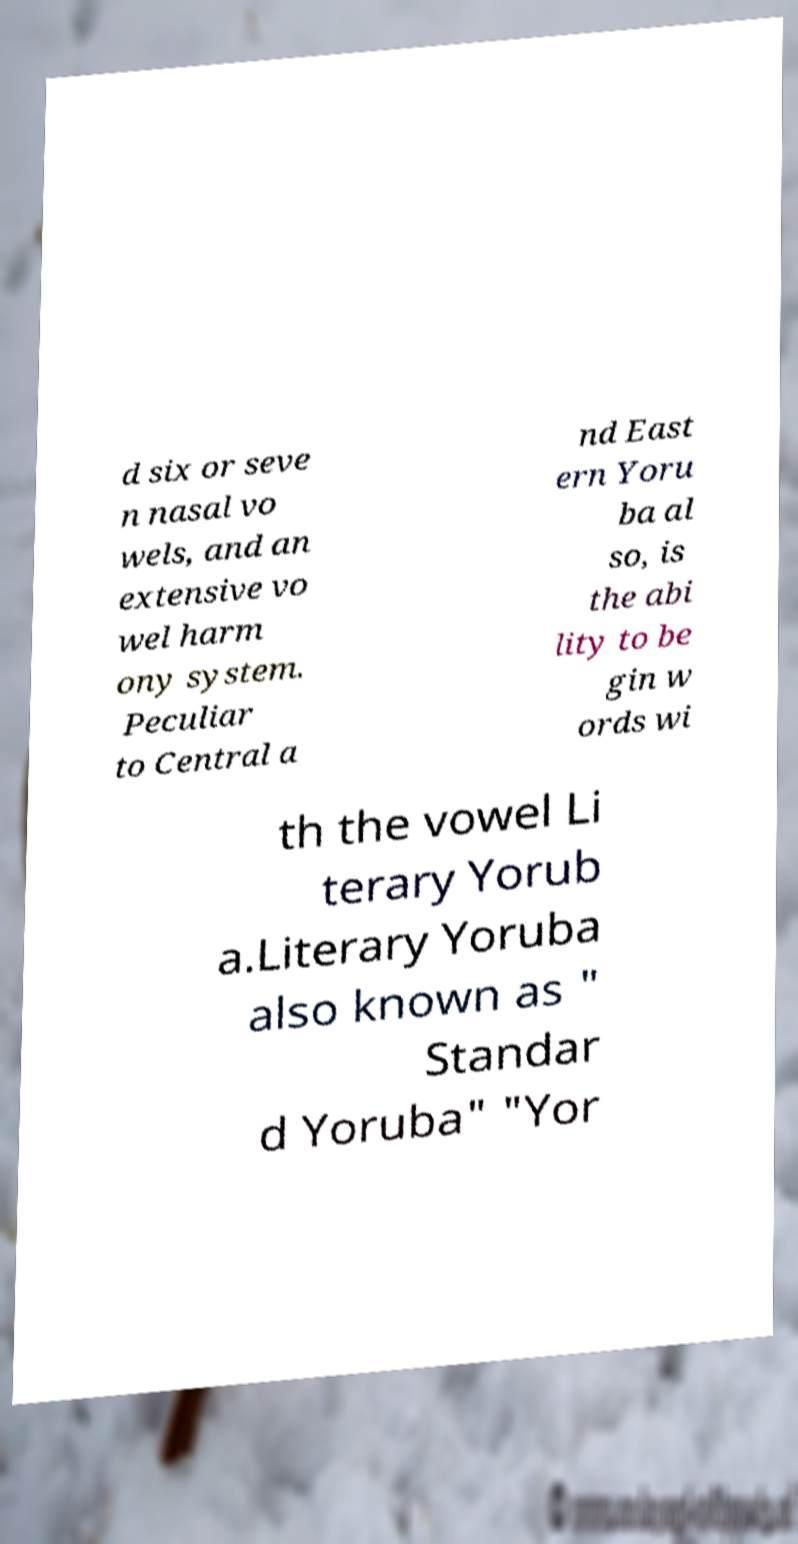Can you accurately transcribe the text from the provided image for me? d six or seve n nasal vo wels, and an extensive vo wel harm ony system. Peculiar to Central a nd East ern Yoru ba al so, is the abi lity to be gin w ords wi th the vowel Li terary Yorub a.Literary Yoruba also known as " Standar d Yoruba" "Yor 